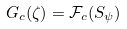Convert formula to latex. <formula><loc_0><loc_0><loc_500><loc_500>G _ { c } ( \zeta ) = \mathcal { F } _ { c } ( S _ { \psi } )</formula> 